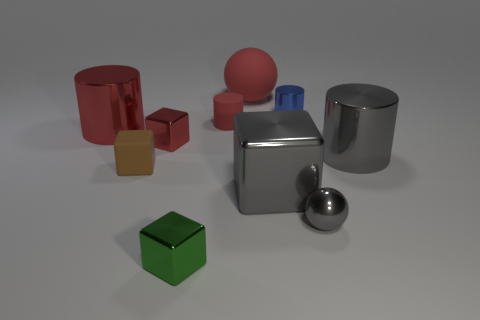What size is the block that is the same color as the rubber cylinder?
Provide a succinct answer. Small. How many cubes are in front of the small brown cube and behind the small green block?
Offer a very short reply. 1. What number of objects are red cubes or shiny cylinders that are in front of the blue shiny thing?
Your response must be concise. 3. The blue thing that is the same material as the large gray cylinder is what size?
Provide a short and direct response. Small. The red rubber thing that is on the left side of the ball that is behind the rubber cube is what shape?
Ensure brevity in your answer.  Cylinder. How many purple things are tiny objects or big shiny cylinders?
Your answer should be compact. 0. Are there any red matte things that are to the left of the large metal thing that is behind the large gray metal thing that is behind the gray metallic block?
Keep it short and to the point. No. There is a small metal object that is the same color as the matte ball; what is its shape?
Offer a terse response. Cube. How many large objects are yellow shiny balls or red blocks?
Your answer should be very brief. 0. There is a big red thing on the left side of the large red ball; does it have the same shape as the tiny blue metallic object?
Offer a very short reply. Yes. 